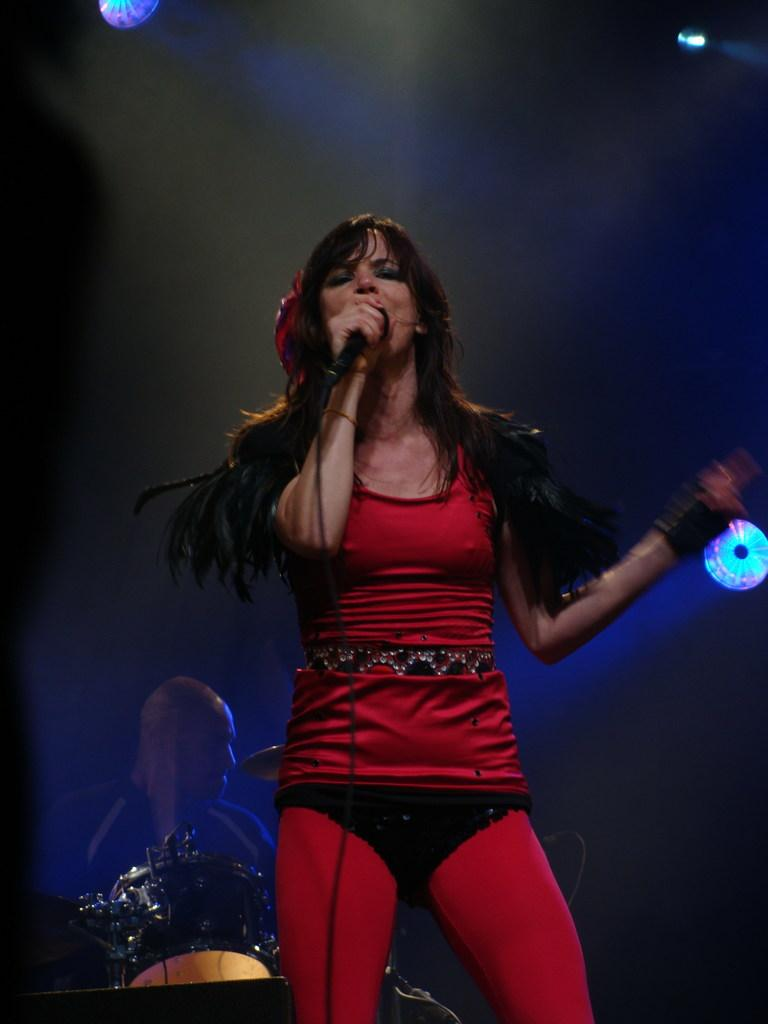Who is the main subject in the image? There is a woman in the image. What is the woman doing in the image? The woman is standing and holding a mic with her hand. Can you describe the background of the image? There is a man visible in the background, along with drums and lights. The background of the image is dark. What type of cat can be seen performing magic tricks in the image? There is no cat or magic tricks present in the image. 